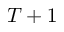<formula> <loc_0><loc_0><loc_500><loc_500>T + 1</formula> 